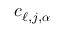Convert formula to latex. <formula><loc_0><loc_0><loc_500><loc_500>c _ { \ell , j , { \alpha } }</formula> 